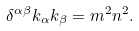<formula> <loc_0><loc_0><loc_500><loc_500>\delta ^ { \alpha \beta } k _ { \alpha } k _ { \beta } = m ^ { 2 } n ^ { 2 } .</formula> 